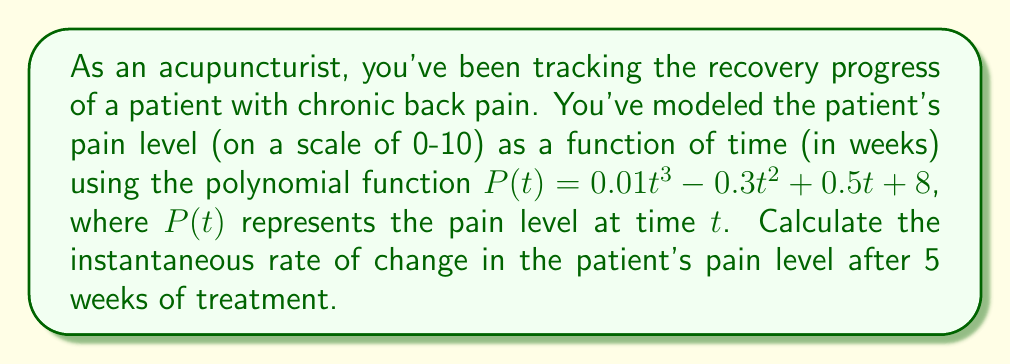Solve this math problem. To find the instantaneous rate of change at a specific point, we need to calculate the derivative of the function and evaluate it at the given point. Let's break this down step-by-step:

1) The given function is:
   $P(t) = 0.01t^3 - 0.3t^2 + 0.5t + 8$

2) To find the derivative, we apply the power rule to each term:
   $P'(t) = 0.03t^2 - 0.6t + 0.5$

3) This derivative function $P'(t)$ represents the instantaneous rate of change of pain level with respect to time.

4) We need to evaluate this at $t = 5$ weeks:
   $P'(5) = 0.03(5)^2 - 0.6(5) + 0.5$

5) Let's calculate this step-by-step:
   $P'(5) = 0.03(25) - 3 + 0.5$
   $P'(5) = 0.75 - 3 + 0.5$
   $P'(5) = -1.75$

The negative value indicates that the pain level is decreasing at this point in time.
Answer: The instantaneous rate of change in the patient's pain level after 5 weeks of treatment is $-1.75$ units per week. 